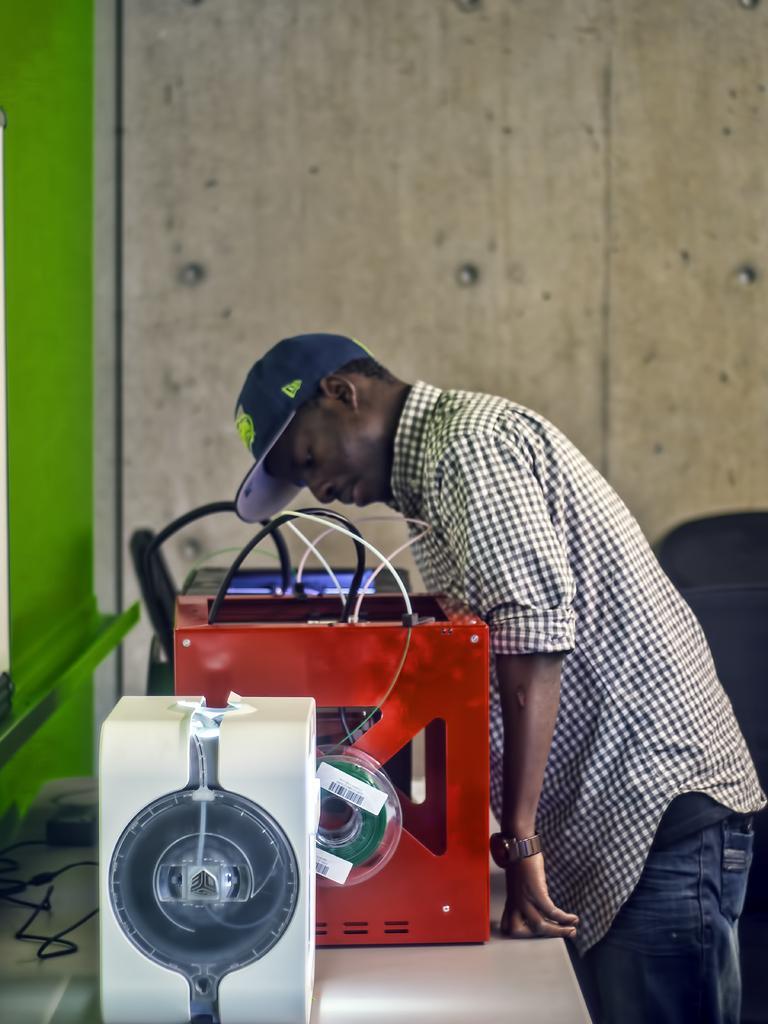Describe this image in one or two sentences. This picture shows a few electronic boxes on the table and we see a man standing and he wore a cap on his head and a wooden wall on the side. 